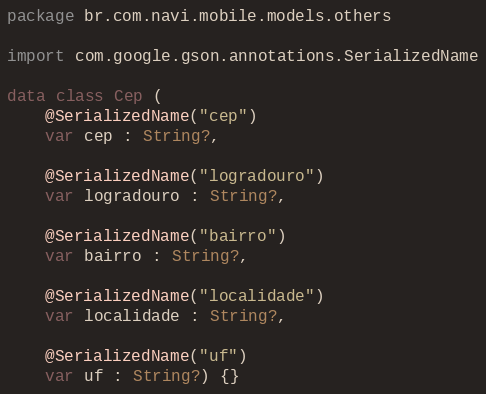Convert code to text. <code><loc_0><loc_0><loc_500><loc_500><_Kotlin_>package br.com.navi.mobile.models.others

import com.google.gson.annotations.SerializedName

data class Cep (
    @SerializedName("cep")
    var cep : String?,

    @SerializedName("logradouro")
    var logradouro : String?,

    @SerializedName("bairro")
    var bairro : String?,

    @SerializedName("localidade")
    var localidade : String?,

    @SerializedName("uf")
    var uf : String?) {}</code> 